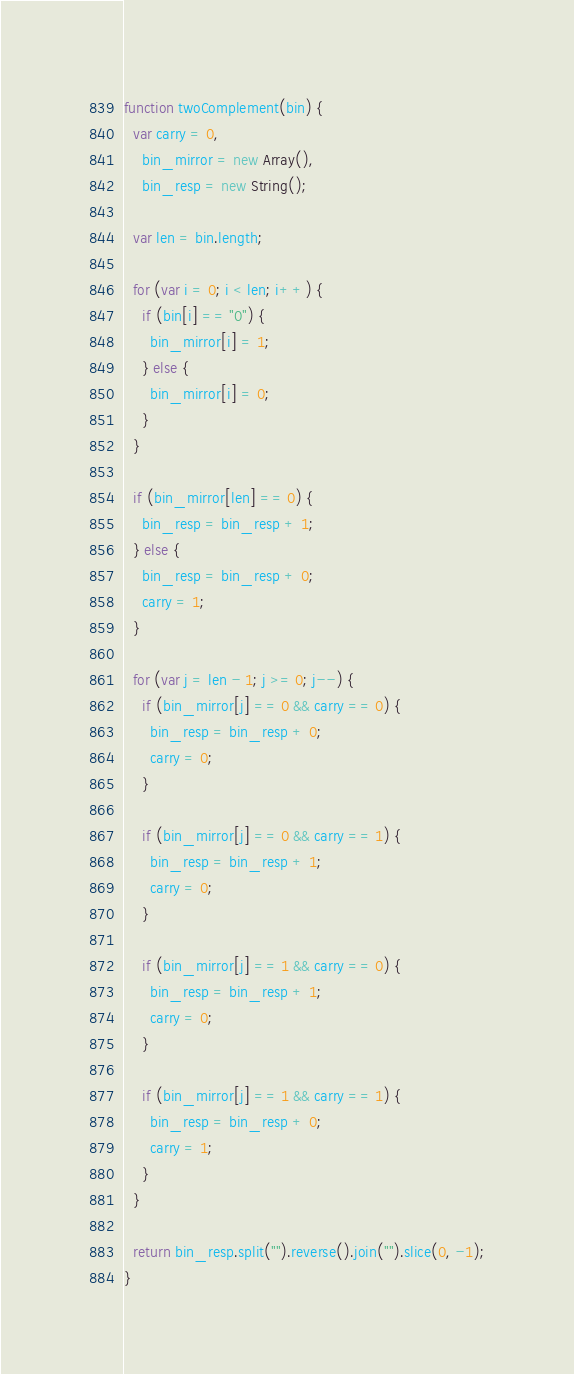Convert code to text. <code><loc_0><loc_0><loc_500><loc_500><_JavaScript_>function twoComplement(bin) {
  var carry = 0,
    bin_mirror = new Array(),
    bin_resp = new String();

  var len = bin.length;

  for (var i = 0; i < len; i++) {
    if (bin[i] == "0") {
      bin_mirror[i] = 1;
    } else {
      bin_mirror[i] = 0;
    }
  }

  if (bin_mirror[len] == 0) {
    bin_resp = bin_resp + 1;
  } else {
    bin_resp = bin_resp + 0;
    carry = 1;
  }

  for (var j = len - 1; j >= 0; j--) {
    if (bin_mirror[j] == 0 && carry == 0) {
      bin_resp = bin_resp + 0;
      carry = 0;
    }

    if (bin_mirror[j] == 0 && carry == 1) {
      bin_resp = bin_resp + 1;
      carry = 0;
    }

    if (bin_mirror[j] == 1 && carry == 0) {
      bin_resp = bin_resp + 1;
      carry = 0;
    }

    if (bin_mirror[j] == 1 && carry == 1) {
      bin_resp = bin_resp + 0;
      carry = 1;
    }
  }

  return bin_resp.split("").reverse().join("").slice(0, -1);
}
</code> 